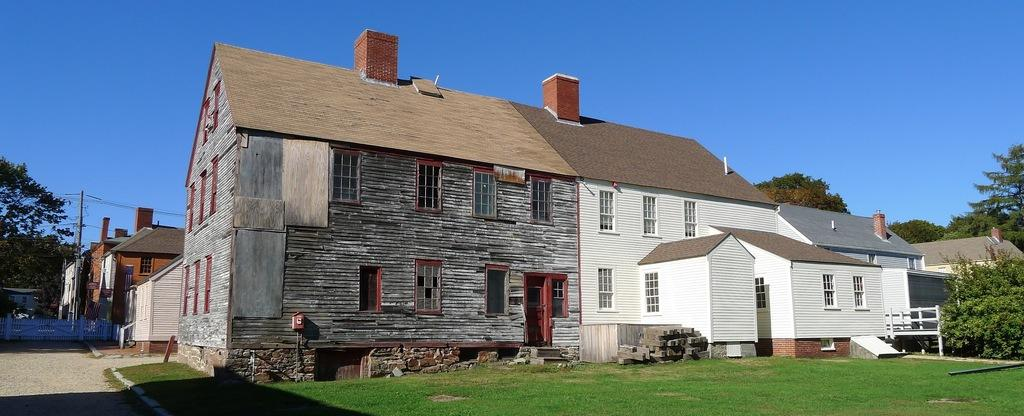What type of houses can be seen in the image? There are wooden houses in the image. What is the ground covered with in the image? Grass is present in the image. What infrastructure elements are visible in the image? Current poles and wires are present in the image. What type of vegetation is in the image? Trees are in the image. What type of barrier is present in the image? There is a fence in the image. What is the color of the sky in the background of the image? The sky in the background is blue. What type of rake is being used to gather leaves in the image? There is no rake present in the image. What nation is represented by the flag in the image? There is no flag present in the image. 